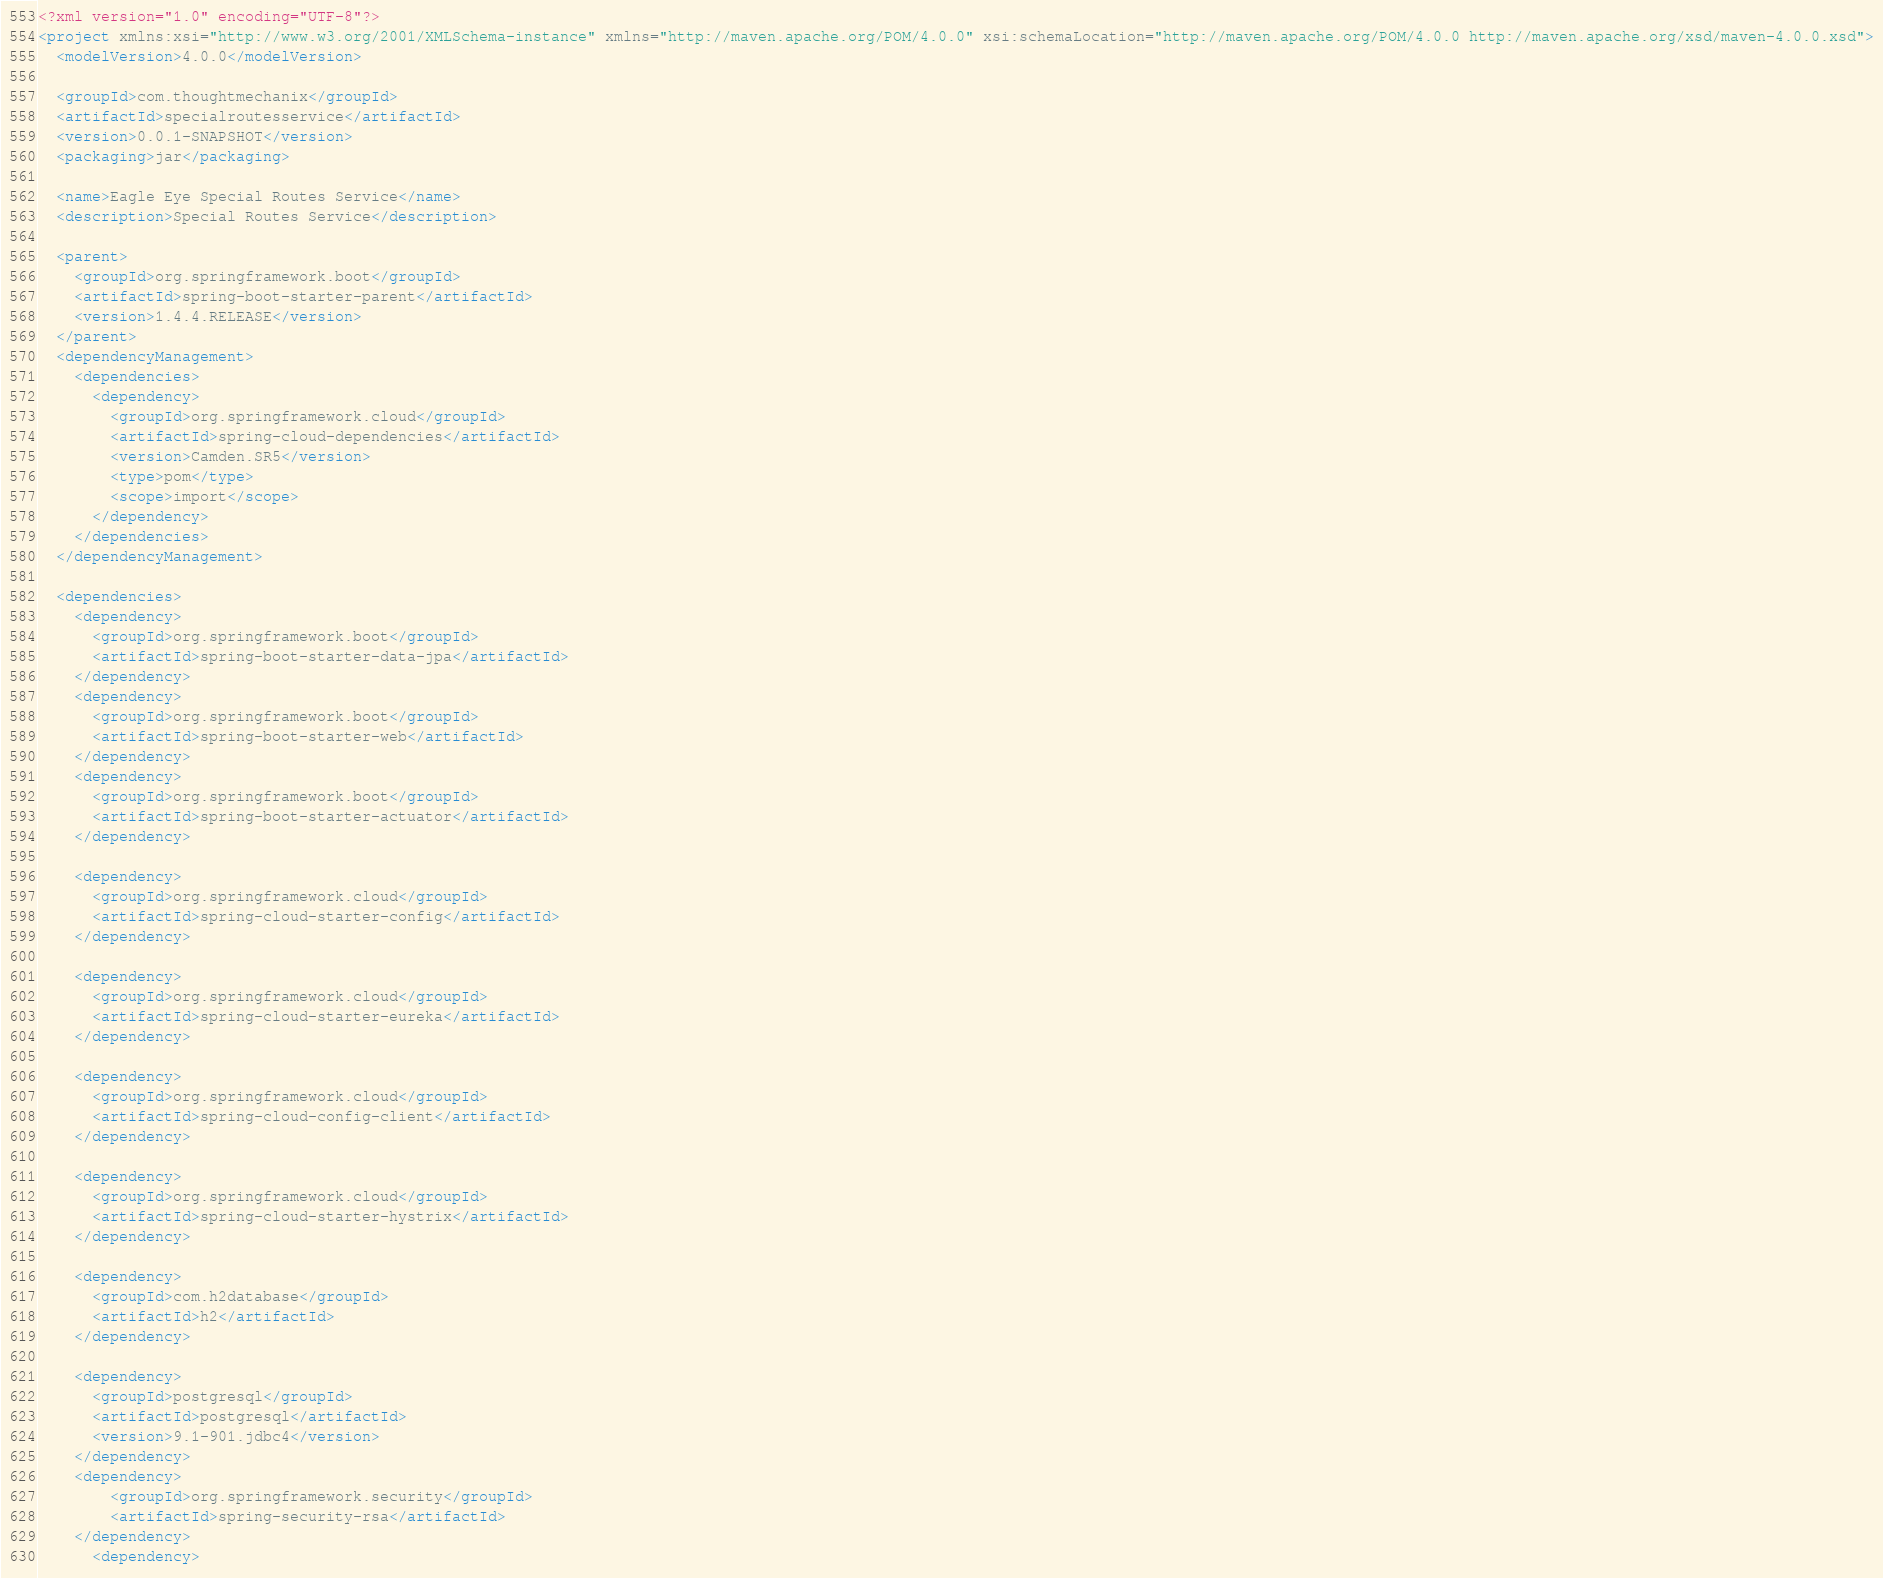<code> <loc_0><loc_0><loc_500><loc_500><_XML_><?xml version="1.0" encoding="UTF-8"?>
<project xmlns:xsi="http://www.w3.org/2001/XMLSchema-instance" xmlns="http://maven.apache.org/POM/4.0.0" xsi:schemaLocation="http://maven.apache.org/POM/4.0.0 http://maven.apache.org/xsd/maven-4.0.0.xsd">
  <modelVersion>4.0.0</modelVersion>

  <groupId>com.thoughtmechanix</groupId>
  <artifactId>specialroutesservice</artifactId>
  <version>0.0.1-SNAPSHOT</version>
  <packaging>jar</packaging>

  <name>Eagle Eye Special Routes Service</name>
  <description>Special Routes Service</description>

  <parent>
    <groupId>org.springframework.boot</groupId>
    <artifactId>spring-boot-starter-parent</artifactId>
    <version>1.4.4.RELEASE</version>
  </parent>
  <dependencyManagement>
    <dependencies>
      <dependency>
        <groupId>org.springframework.cloud</groupId>
        <artifactId>spring-cloud-dependencies</artifactId>
        <version>Camden.SR5</version>
        <type>pom</type>
        <scope>import</scope>
      </dependency>
    </dependencies>
  </dependencyManagement>

  <dependencies>
    <dependency>
      <groupId>org.springframework.boot</groupId>
      <artifactId>spring-boot-starter-data-jpa</artifactId>
    </dependency>
    <dependency>
      <groupId>org.springframework.boot</groupId>
      <artifactId>spring-boot-starter-web</artifactId>
    </dependency>
    <dependency>
      <groupId>org.springframework.boot</groupId>
      <artifactId>spring-boot-starter-actuator</artifactId>
    </dependency>

    <dependency>
      <groupId>org.springframework.cloud</groupId>
      <artifactId>spring-cloud-starter-config</artifactId>
    </dependency>

    <dependency>
      <groupId>org.springframework.cloud</groupId>
      <artifactId>spring-cloud-starter-eureka</artifactId>
    </dependency>

    <dependency>
      <groupId>org.springframework.cloud</groupId>
      <artifactId>spring-cloud-config-client</artifactId>
    </dependency>

    <dependency>
      <groupId>org.springframework.cloud</groupId>
      <artifactId>spring-cloud-starter-hystrix</artifactId>
    </dependency>

    <dependency>
      <groupId>com.h2database</groupId>
      <artifactId>h2</artifactId>
    </dependency>

    <dependency>
      <groupId>postgresql</groupId>
      <artifactId>postgresql</artifactId>
      <version>9.1-901.jdbc4</version>
    </dependency>
    <dependency>
        <groupId>org.springframework.security</groupId>
        <artifactId>spring-security-rsa</artifactId>
    </dependency>
      <dependency></code> 